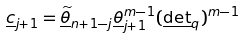Convert formula to latex. <formula><loc_0><loc_0><loc_500><loc_500>\underline { c } _ { j + 1 } = \underline { \widetilde { \theta } } _ { n + 1 - j } \underline { \theta } _ { j + 1 } ^ { m - 1 } ( \underline { \det } _ { q } ) ^ { m - 1 }</formula> 